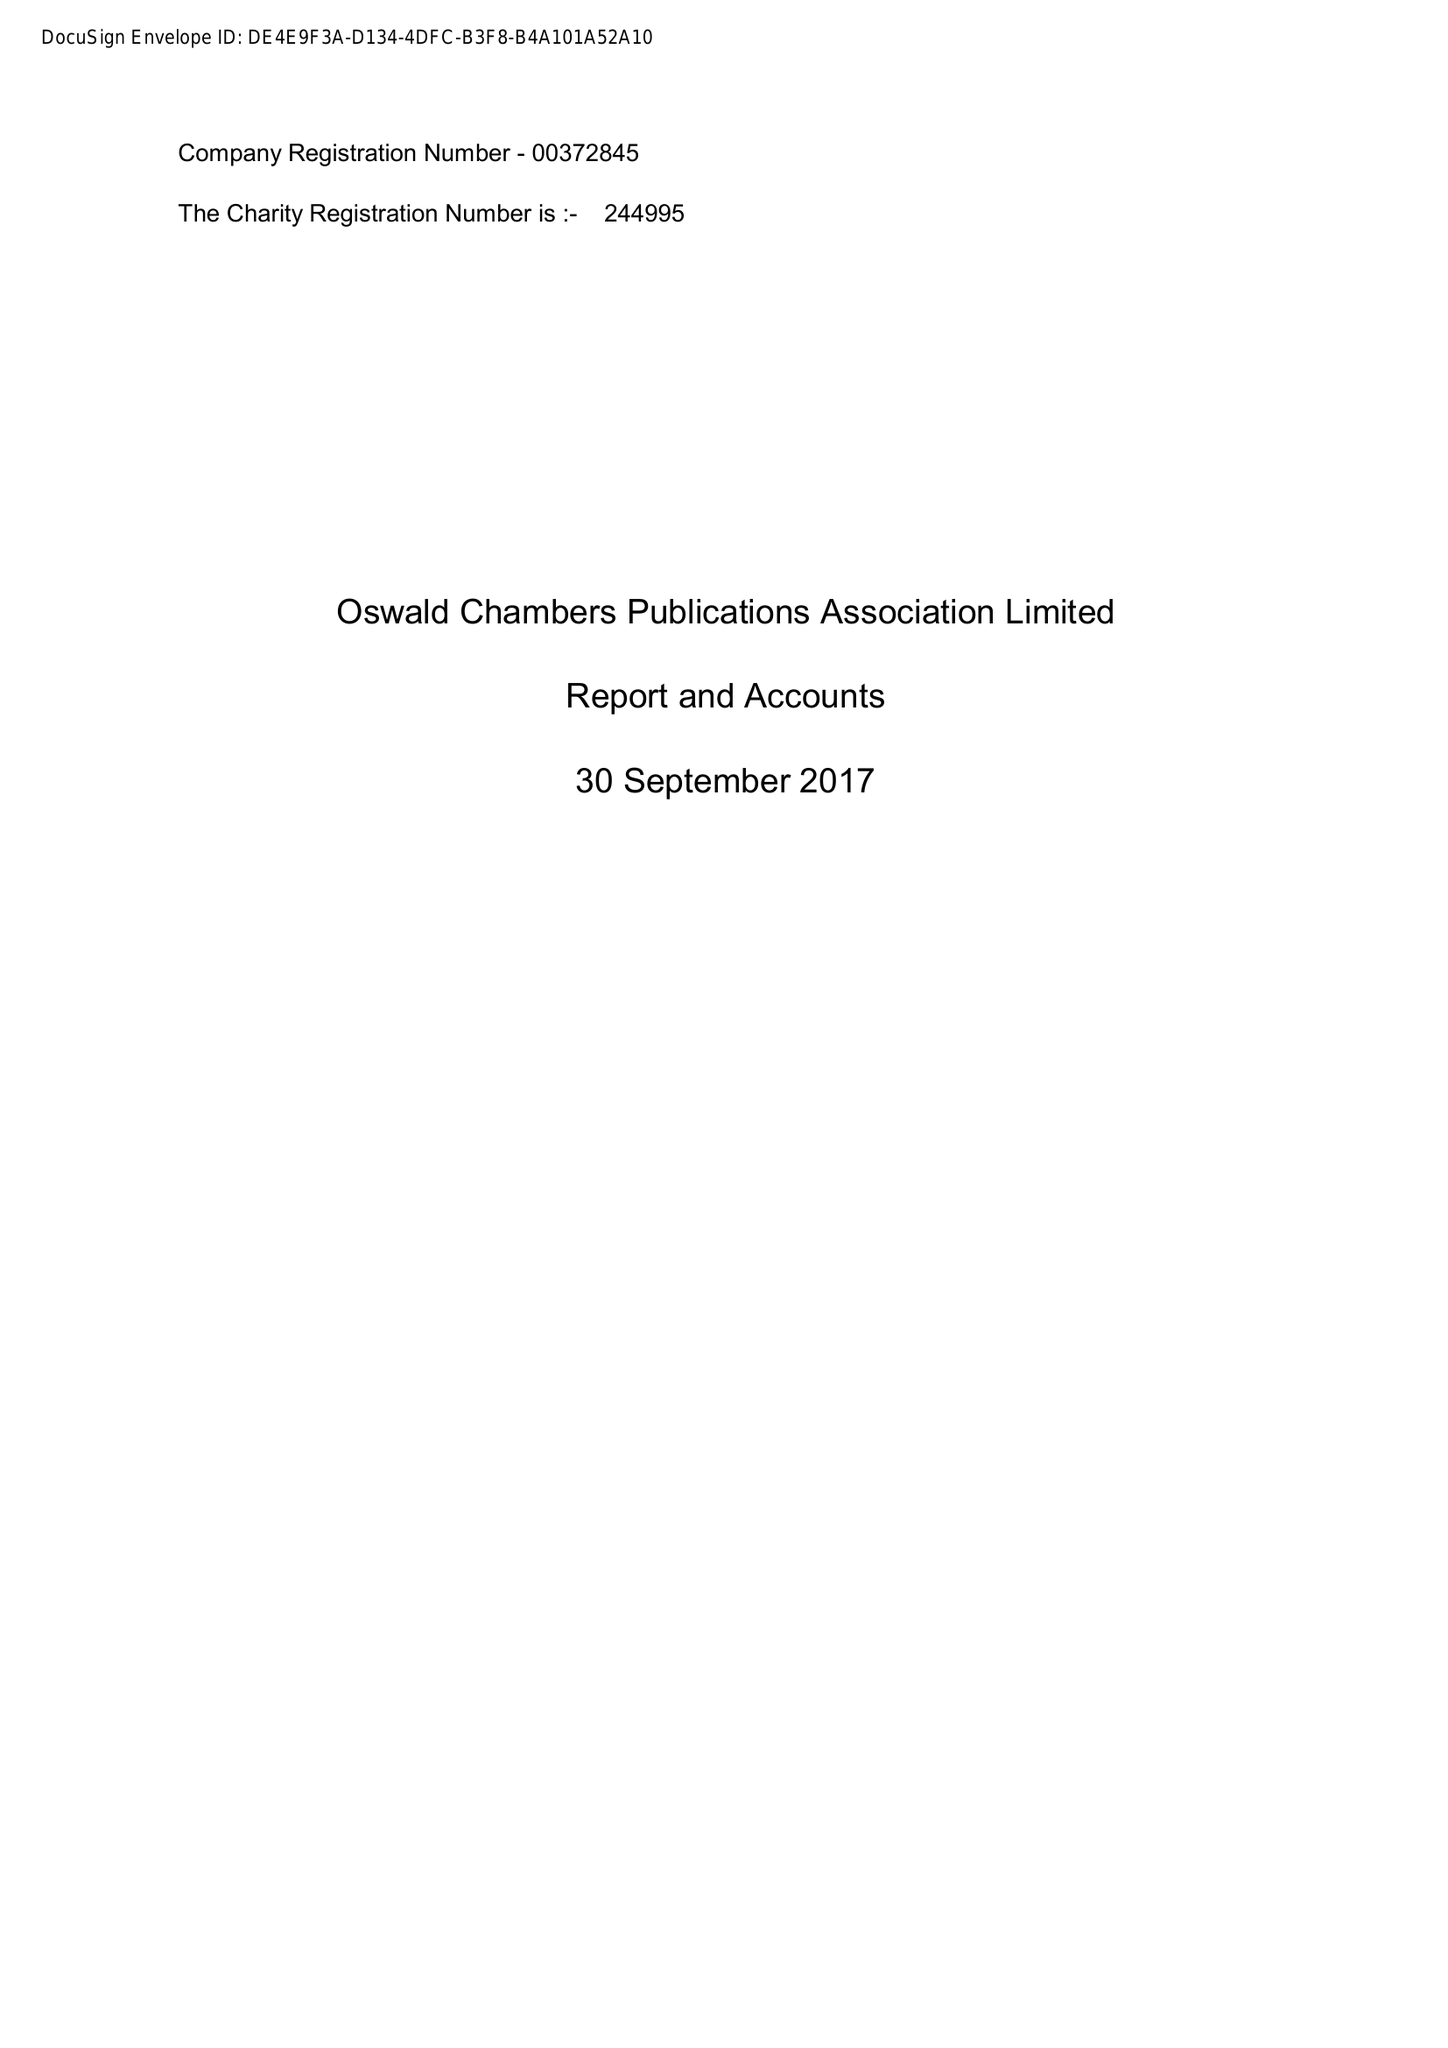What is the value for the charity_number?
Answer the question using a single word or phrase. 244995 